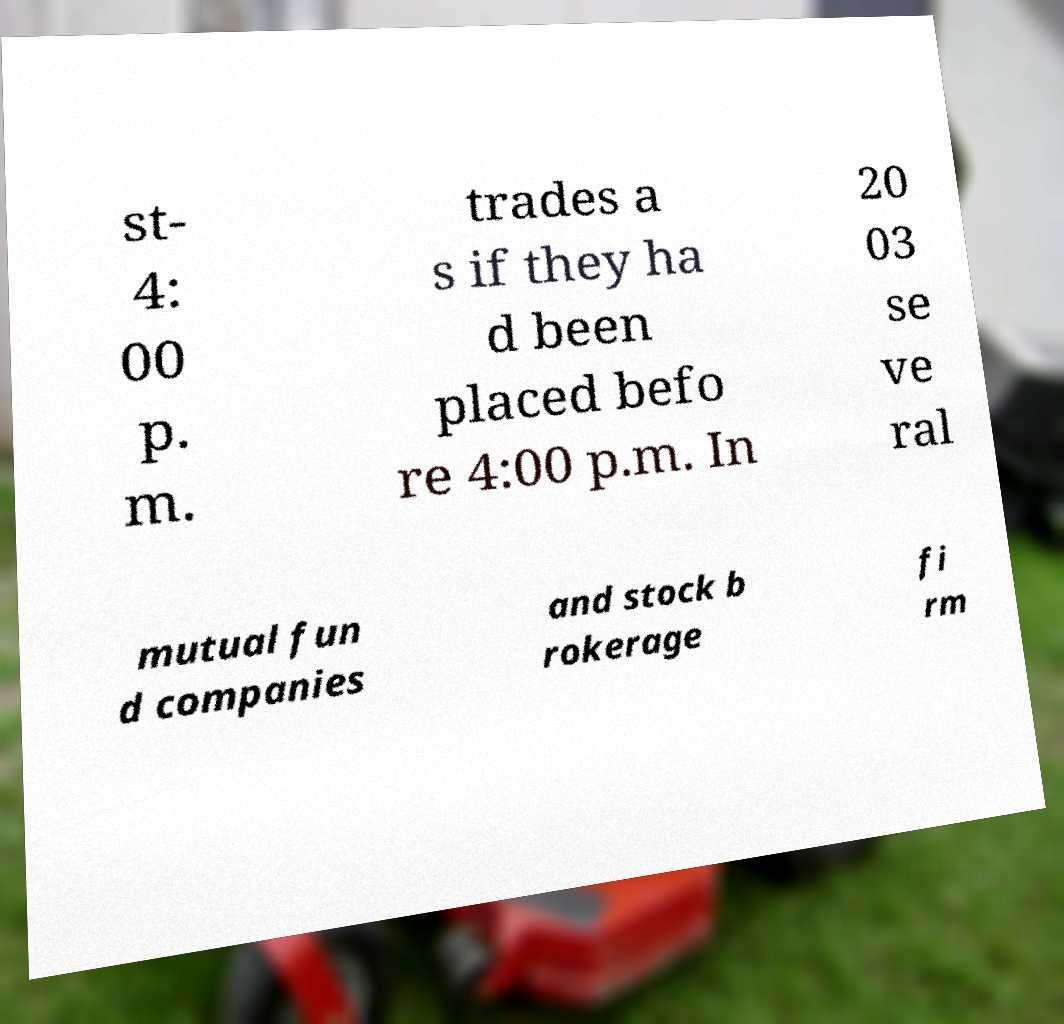Please read and relay the text visible in this image. What does it say? st- 4: 00 p. m. trades a s if they ha d been placed befo re 4:00 p.m. In 20 03 se ve ral mutual fun d companies and stock b rokerage fi rm 